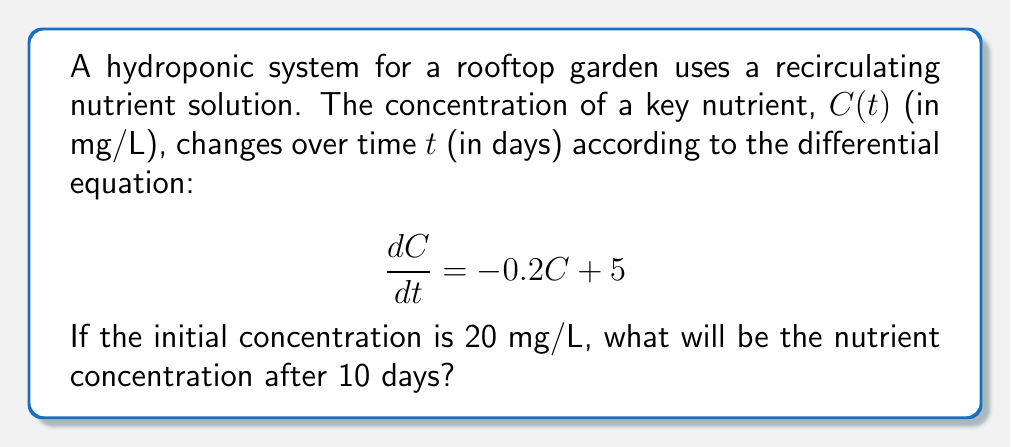Can you answer this question? To solve this problem, we need to use the method for solving first-order linear differential equations.

1) The general form of a first-order linear differential equation is:

   $$\frac{dy}{dx} + P(x)y = Q(x)$$

2) In our case, $\frac{dC}{dt} = -0.2C + 5$, so $P(t) = 0.2$ and $Q(t) = 5$

3) The general solution for this type of equation is:

   $$y = e^{-\int P(x)dx} \left(\int Q(x)e^{\int P(x)dx}dx + C\right)$$

4) Let's solve step by step:
   
   $\int P(t)dt = \int 0.2dt = 0.2t$
   
   $e^{\int P(t)dt} = e^{0.2t}$

5) Now, we can write:

   $$C = e^{-0.2t} \left(\int 5e^{0.2t}dt + K\right)$$

6) Solving the integral:

   $$\int 5e^{0.2t}dt = 5 \cdot \frac{1}{0.2}e^{0.2t} = 25e^{0.2t}$$

7) So our general solution is:

   $$C = e^{-0.2t} (25e^{0.2t} + K) = 25 + Ke^{-0.2t}$$

8) To find $K$, we use the initial condition $C(0) = 20$:

   $$20 = 25 + K$$
   $$K = -5$$

9) Therefore, the particular solution is:

   $$C(t) = 25 - 5e^{-0.2t}$$

10) To find the concentration after 10 days, we calculate $C(10)$:

    $$C(10) = 25 - 5e^{-0.2 \cdot 10} = 25 - 5e^{-2} \approx 24.32$$
Answer: The nutrient concentration after 10 days will be approximately 24.32 mg/L. 